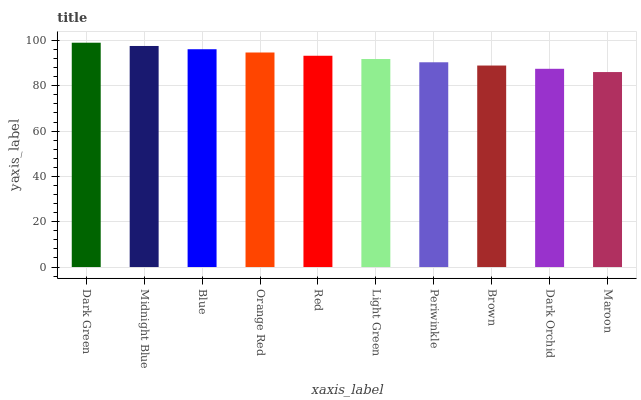Is Maroon the minimum?
Answer yes or no. Yes. Is Dark Green the maximum?
Answer yes or no. Yes. Is Midnight Blue the minimum?
Answer yes or no. No. Is Midnight Blue the maximum?
Answer yes or no. No. Is Dark Green greater than Midnight Blue?
Answer yes or no. Yes. Is Midnight Blue less than Dark Green?
Answer yes or no. Yes. Is Midnight Blue greater than Dark Green?
Answer yes or no. No. Is Dark Green less than Midnight Blue?
Answer yes or no. No. Is Red the high median?
Answer yes or no. Yes. Is Light Green the low median?
Answer yes or no. Yes. Is Orange Red the high median?
Answer yes or no. No. Is Maroon the low median?
Answer yes or no. No. 